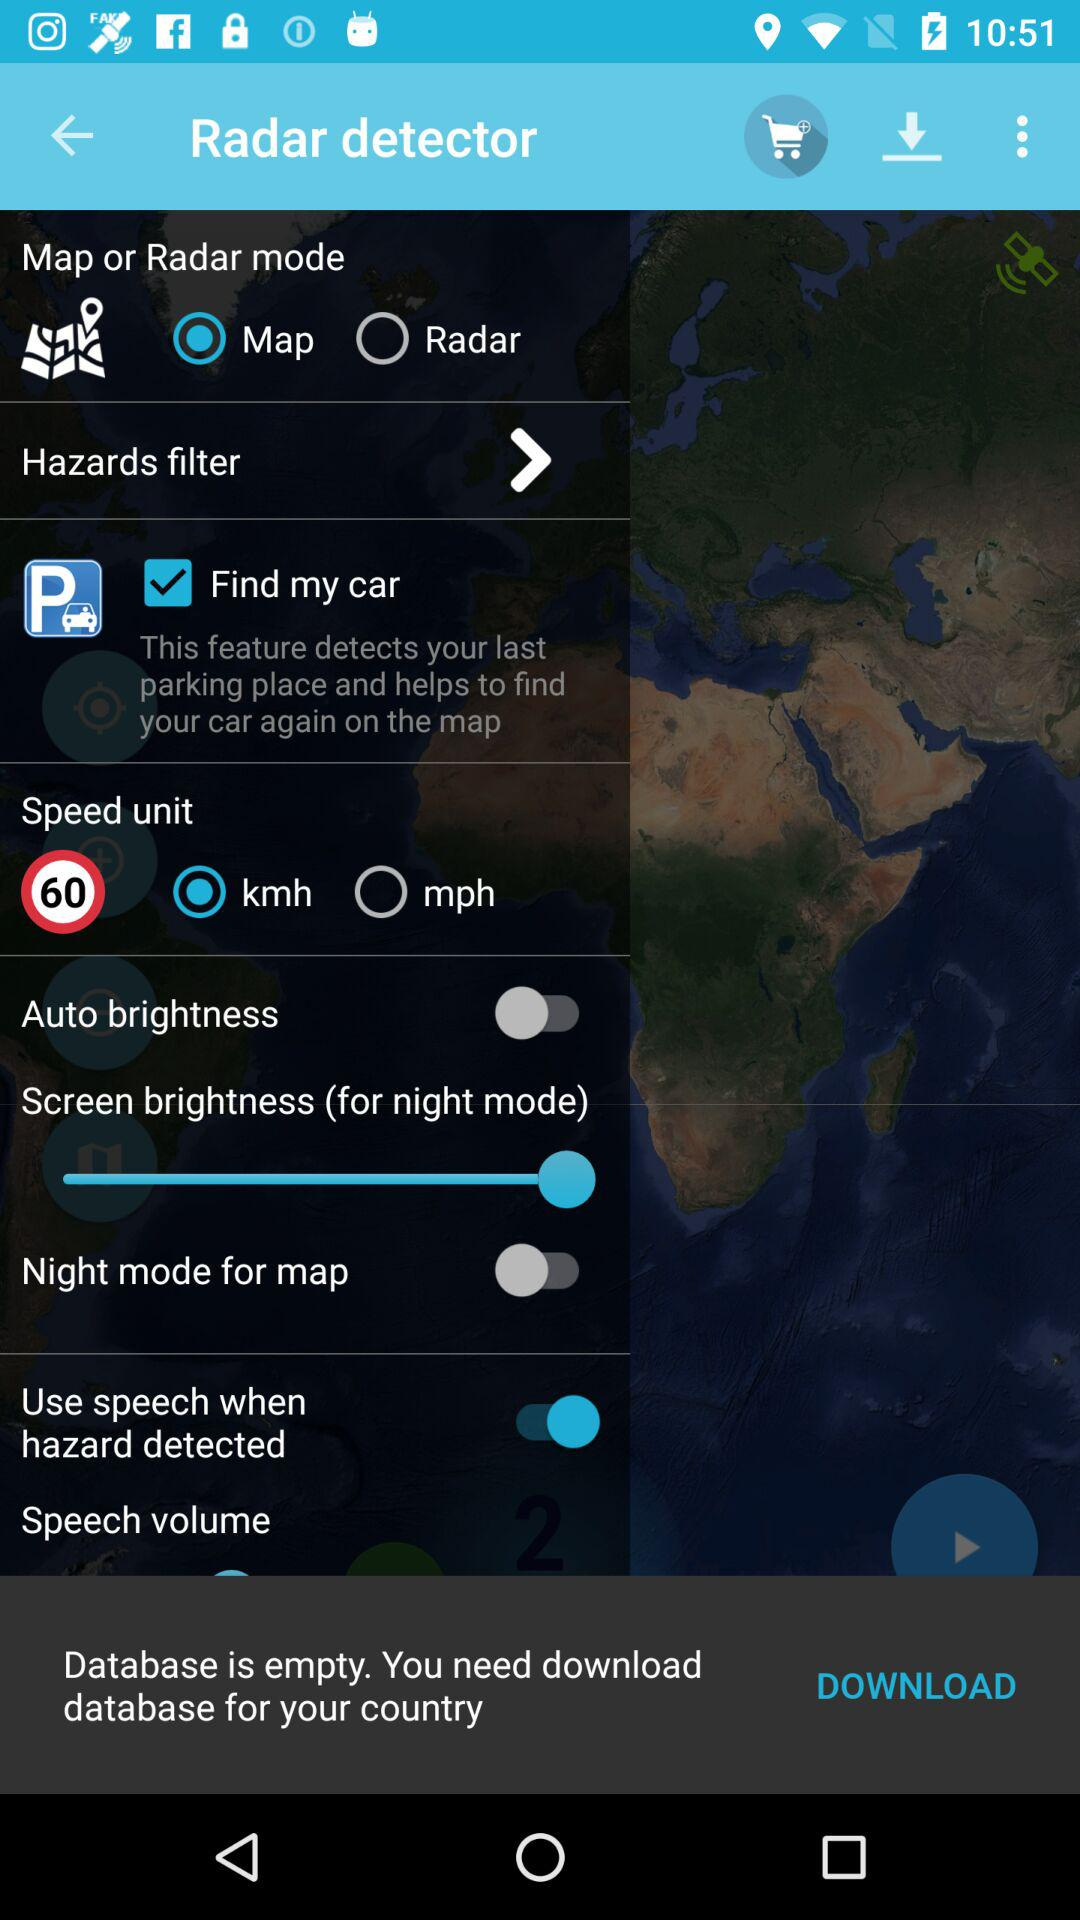Which option was selected in "Map or Radar mode"? The selected option in "Map or Radar mode" is "Map". 